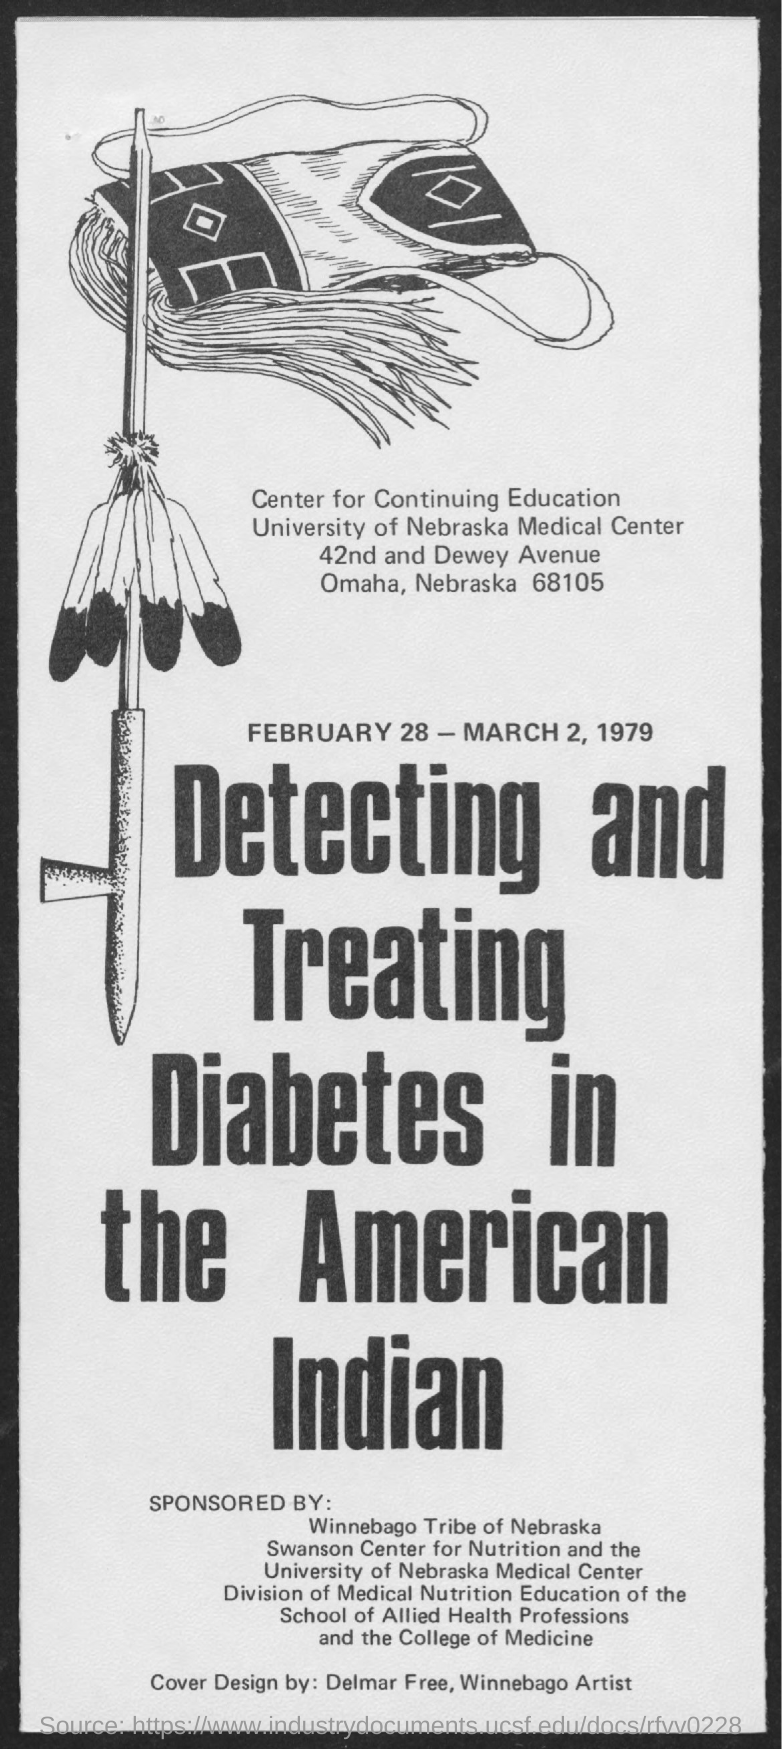Whate are the dates of the program?
Your answer should be compact. February 28-March 2, 1979. Which person designed the cover?
Give a very brief answer. Delmar Free,Winnebago Artist. 